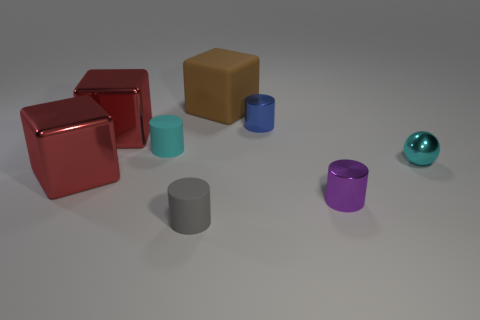What time of day do you think this scene is set in? It's difficult to determine the time of day as the scene is likely set indoors under uniform lighting, which does not provide any specific clues about the time. What suggests that it's indoors? The lack of shadows indicating direct sunlight, the consistent lighting over all objects, and the neutral background all suggest an indoor setting with artificial lighting. 